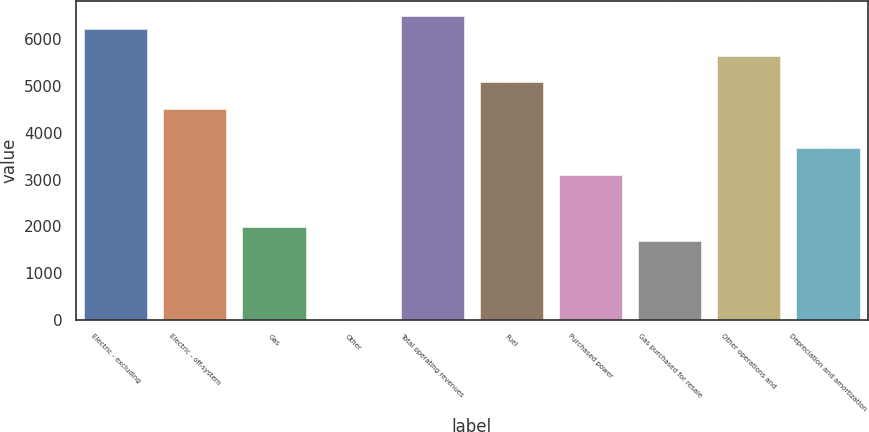Convert chart to OTSL. <chart><loc_0><loc_0><loc_500><loc_500><bar_chart><fcel>Electric - excluding<fcel>Electric - off-system<fcel>Gas<fcel>Other<fcel>Total operating revenues<fcel>Fuel<fcel>Purchased power<fcel>Gas purchased for resale<fcel>Other operations and<fcel>Depreciation and amortization<nl><fcel>6208.2<fcel>4515.6<fcel>1976.7<fcel>2<fcel>6490.3<fcel>5079.8<fcel>3105.1<fcel>1694.6<fcel>5644<fcel>3669.3<nl></chart> 